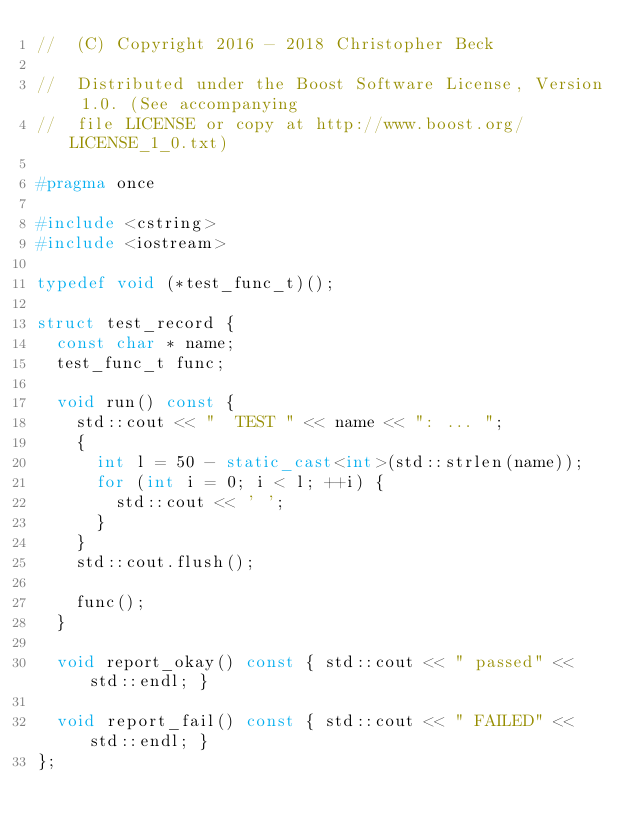<code> <loc_0><loc_0><loc_500><loc_500><_C++_>//  (C) Copyright 2016 - 2018 Christopher Beck

//  Distributed under the Boost Software License, Version 1.0. (See accompanying
//  file LICENSE or copy at http://www.boost.org/LICENSE_1_0.txt)

#pragma once

#include <cstring>
#include <iostream>

typedef void (*test_func_t)();

struct test_record {
  const char * name;
  test_func_t func;

  void run() const {
    std::cout << "  TEST " << name << ": ... ";
    {
      int l = 50 - static_cast<int>(std::strlen(name));
      for (int i = 0; i < l; ++i) {
        std::cout << ' ';
      }
    }
    std::cout.flush();

    func();
  }

  void report_okay() const { std::cout << " passed" << std::endl; }

  void report_fail() const { std::cout << " FAILED" << std::endl; }
};
</code> 